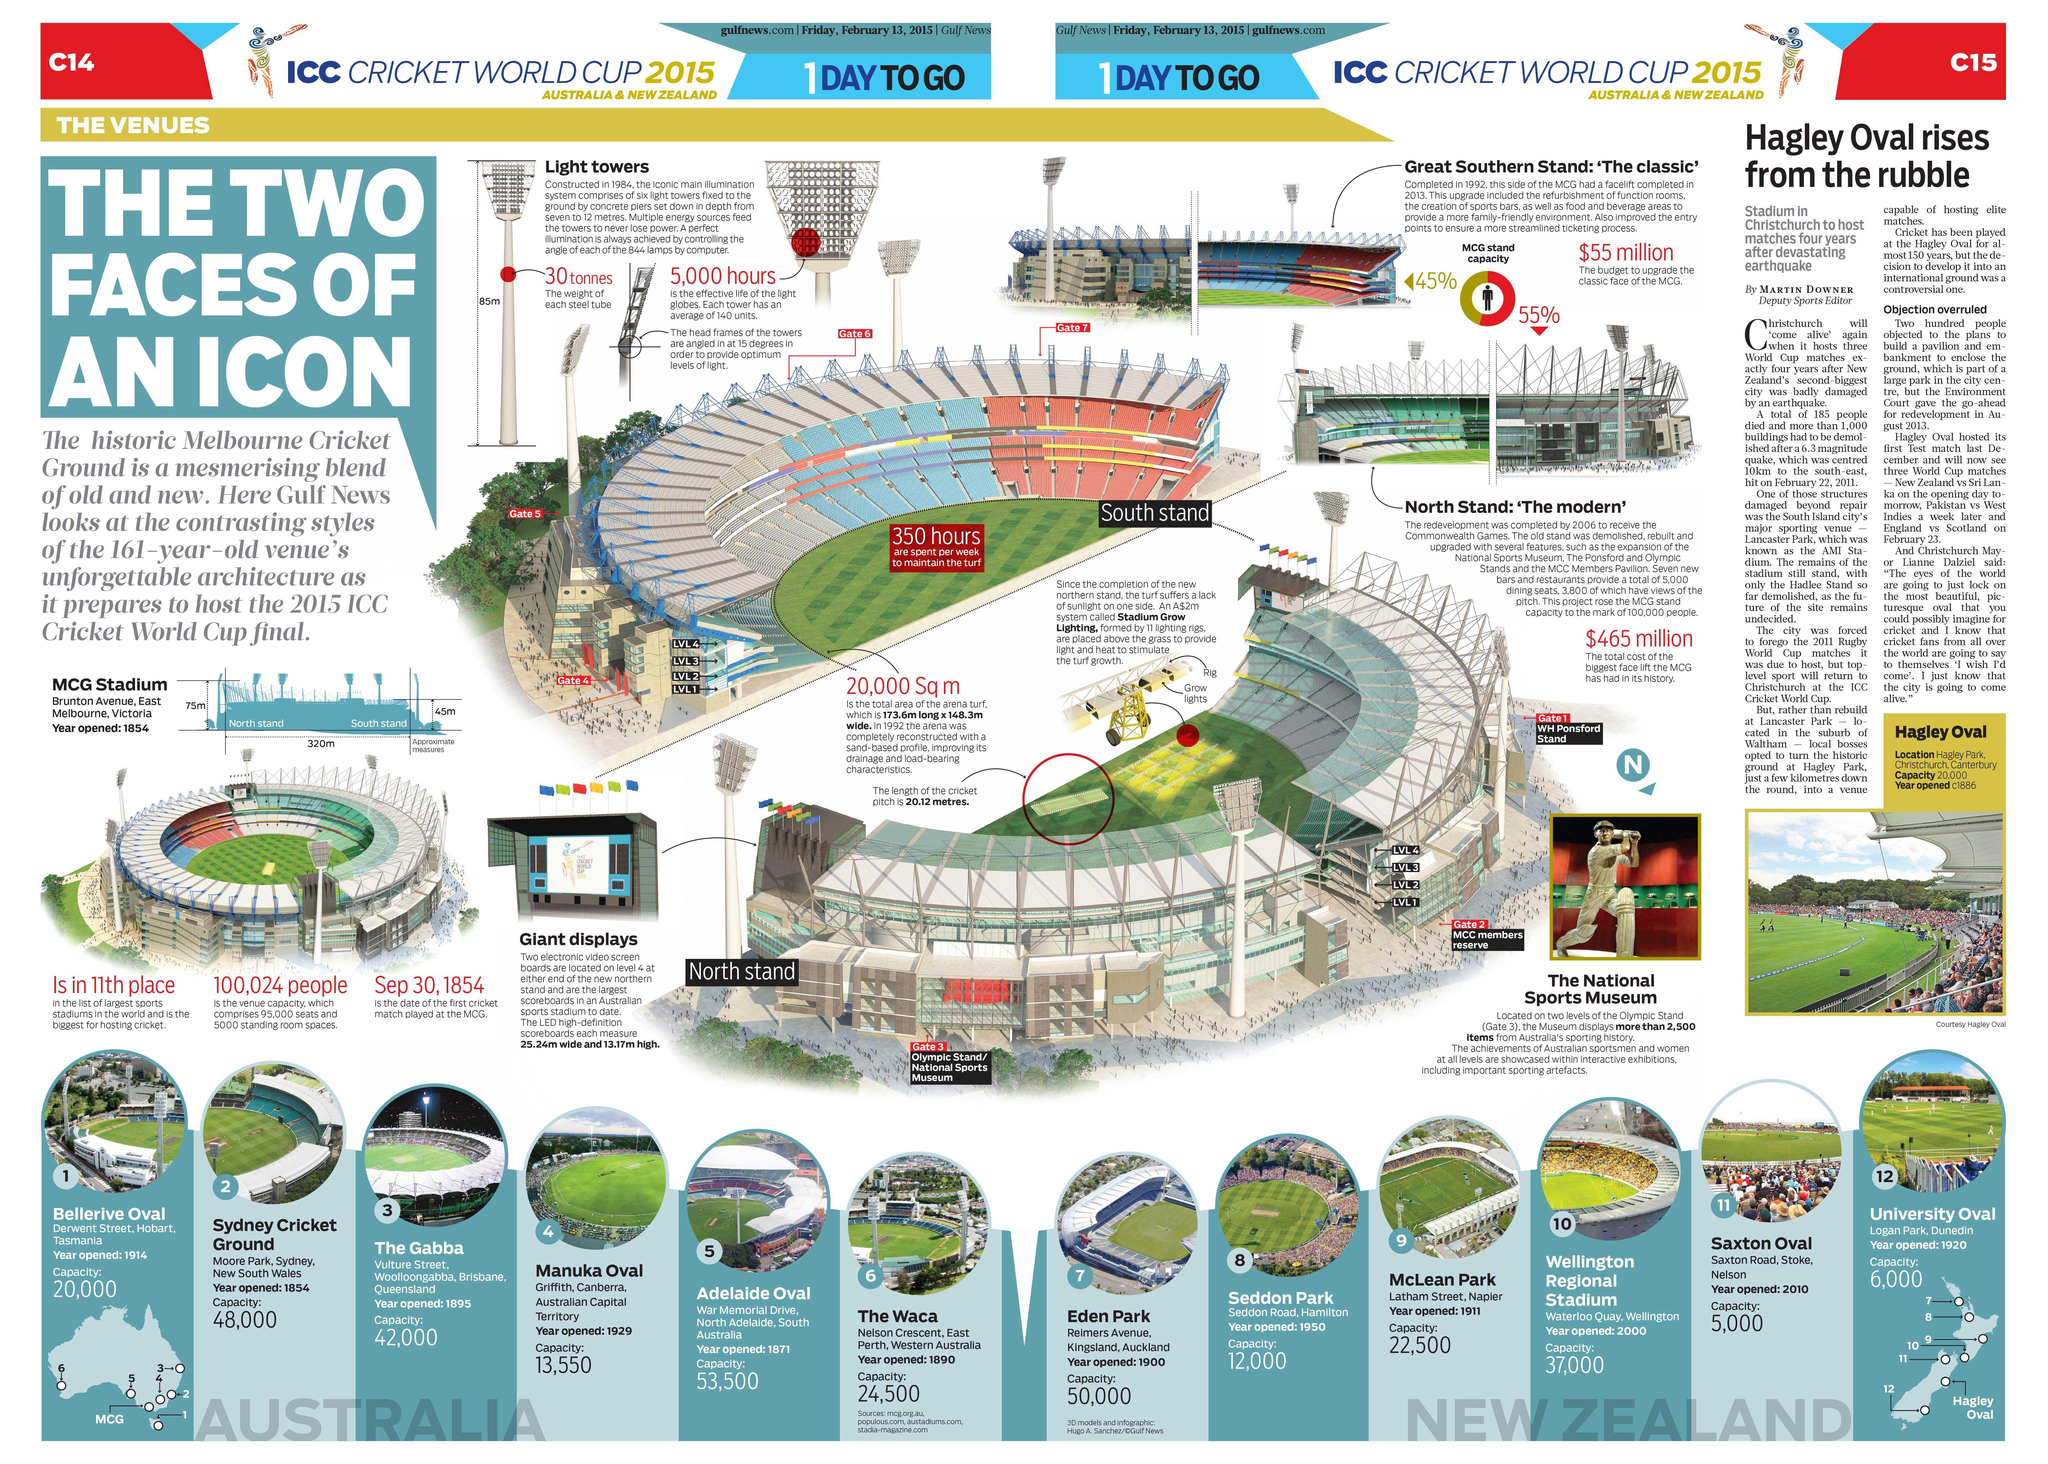How many stadiums are opened after 1901?
Answer the question with a short phrase. 7 How many stadiums have a capacity of less than 20,000? 4 How many stadiums are opened before 1901? 5 How many stadiums have a capacity of  20,000 to 50,000? 7 How many stadiums have a capacity of more than or equal to 50,000? 2 